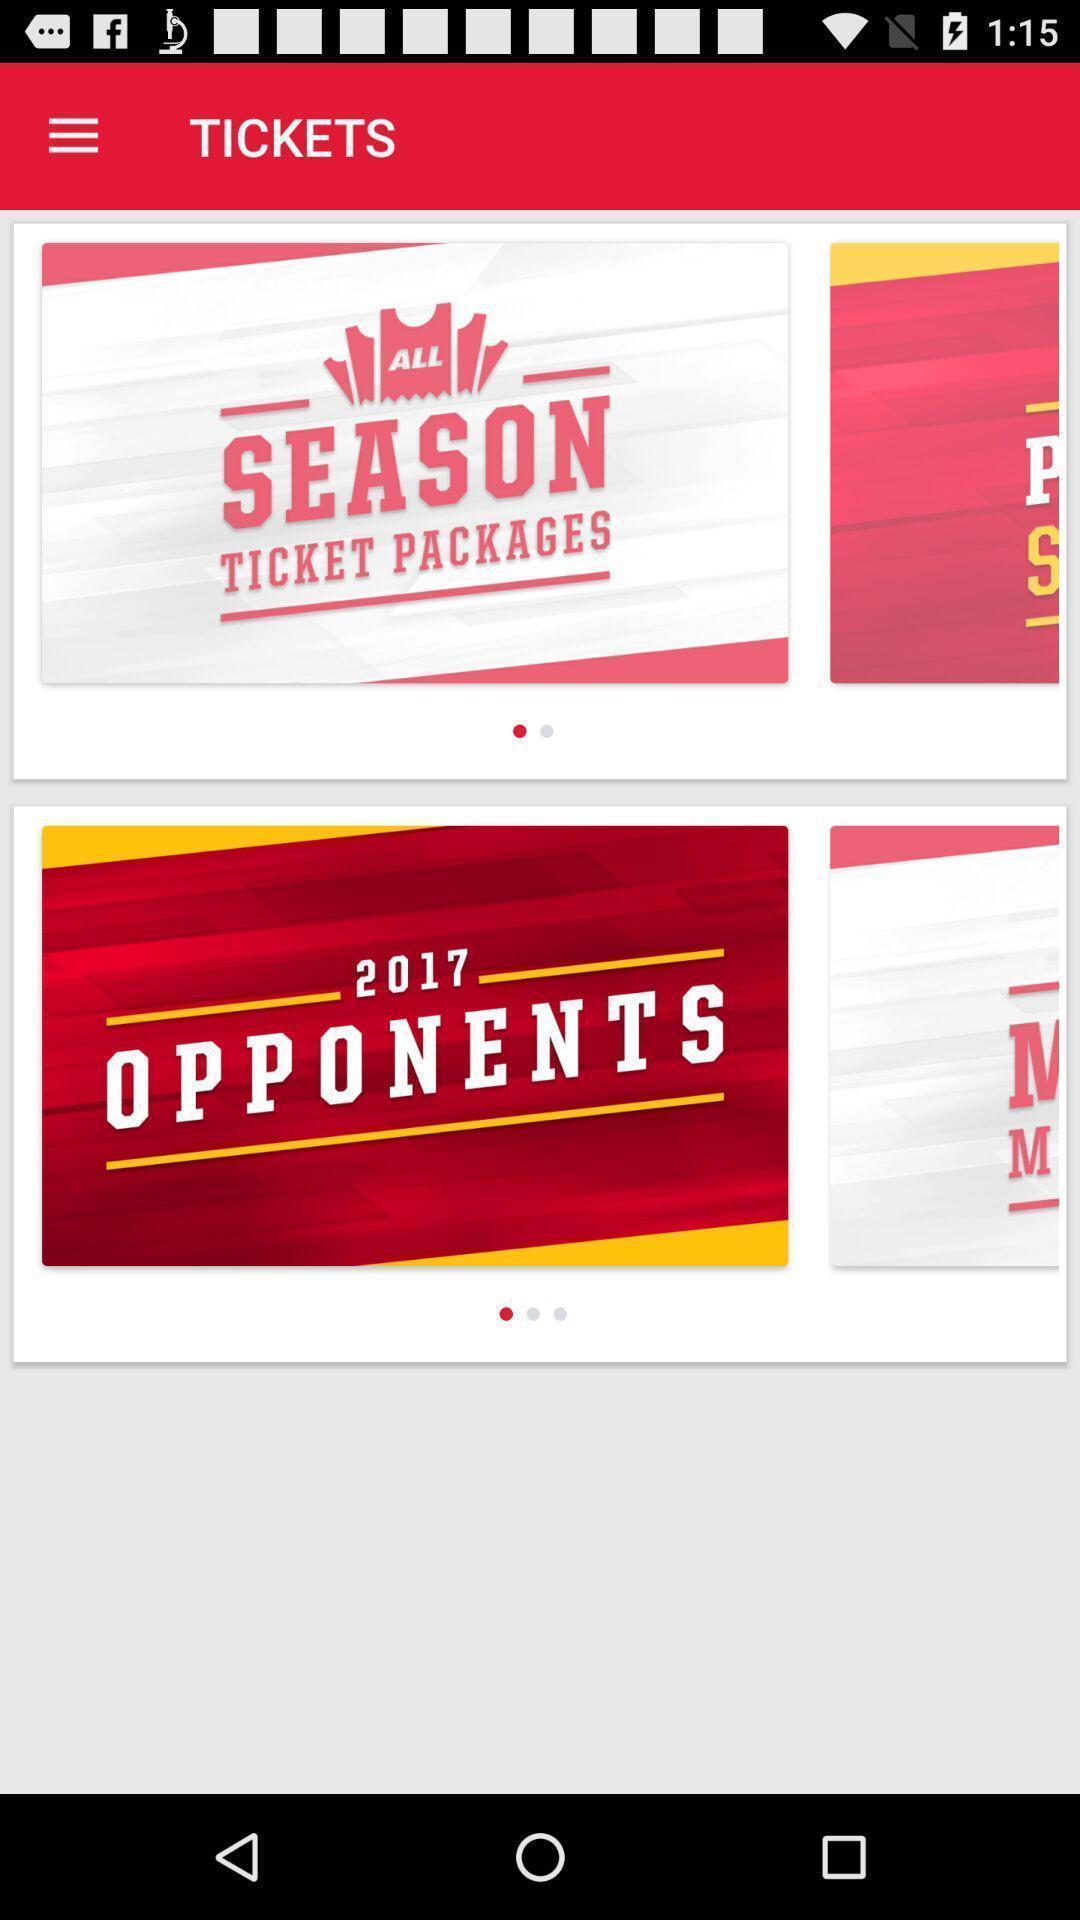Describe the key features of this screenshot. Screen shows tickets details. 